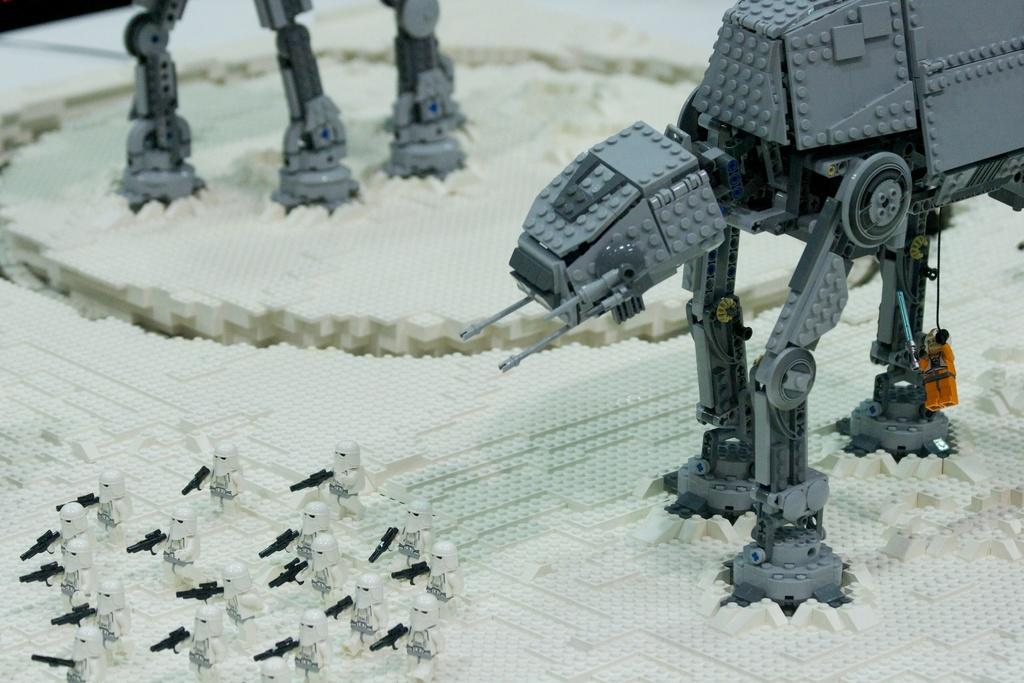What is the primary location of the objects in the image? The objects are on a platform in the image. Who is the expert sitting on the throne in the image? There is no throne or expert present in the image; it only shows objects on a platform. 